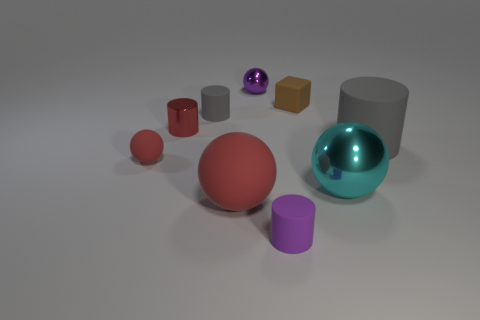Subtract 1 balls. How many balls are left? 3 Subtract all cubes. How many objects are left? 8 Subtract 0 green cylinders. How many objects are left? 9 Subtract all tiny red objects. Subtract all small red rubber balls. How many objects are left? 6 Add 3 tiny purple matte objects. How many tiny purple matte objects are left? 4 Add 8 cyan balls. How many cyan balls exist? 9 